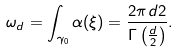Convert formula to latex. <formula><loc_0><loc_0><loc_500><loc_500>\omega _ { d } = \int _ { \gamma _ { 0 } } \alpha ( \xi ) = \frac { 2 \pi ^ { } { d } 2 } { \Gamma \left ( \frac { d } { 2 } \right ) } .</formula> 